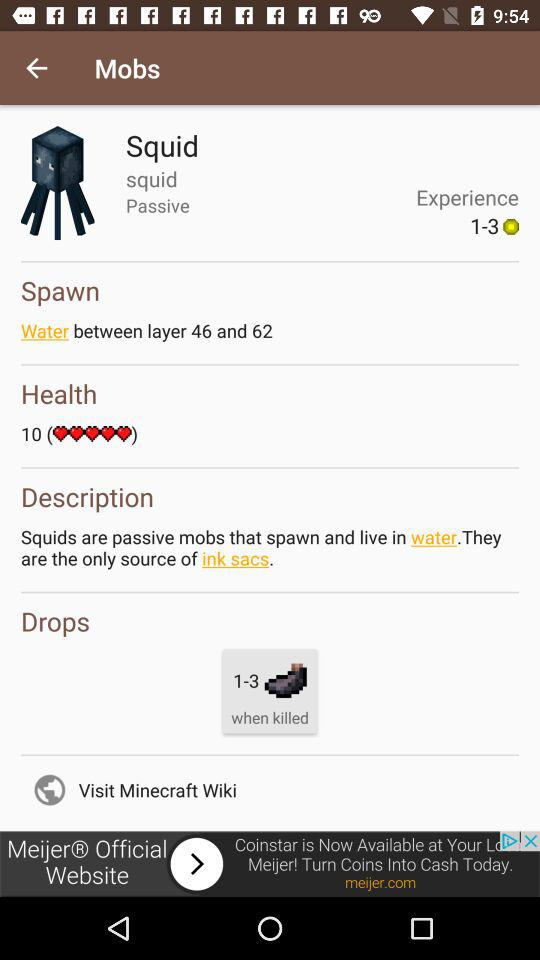What is the experience? The experience is 1-3. 